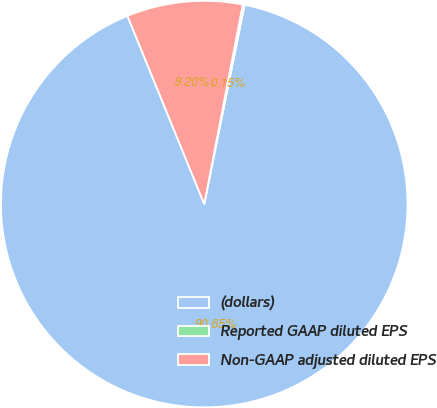Convert chart. <chart><loc_0><loc_0><loc_500><loc_500><pie_chart><fcel>(dollars)<fcel>Reported GAAP diluted EPS<fcel>Non-GAAP adjusted diluted EPS<nl><fcel>90.65%<fcel>0.15%<fcel>9.2%<nl></chart> 